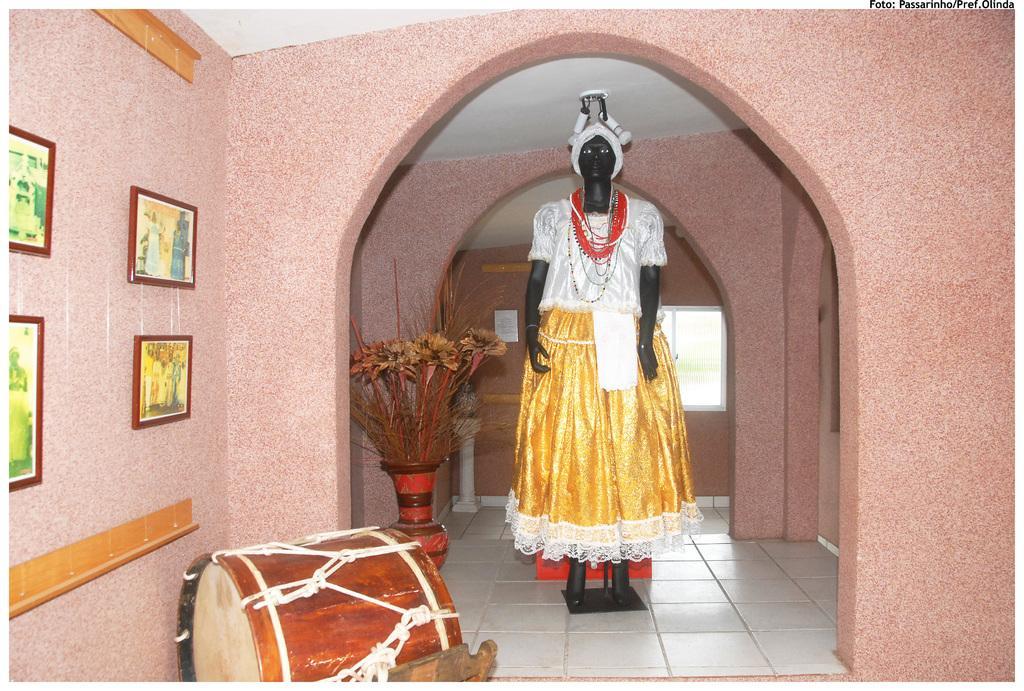Please provide a concise description of this image. In this image i can see a doll standing at the left there are few frames attached to a wall, at the back ground there is a flower pot. 